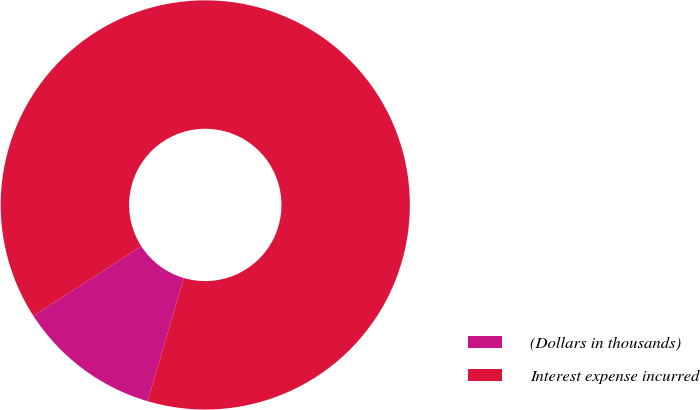<chart> <loc_0><loc_0><loc_500><loc_500><pie_chart><fcel>(Dollars in thousands)<fcel>Interest expense incurred<nl><fcel>11.33%<fcel>88.67%<nl></chart> 